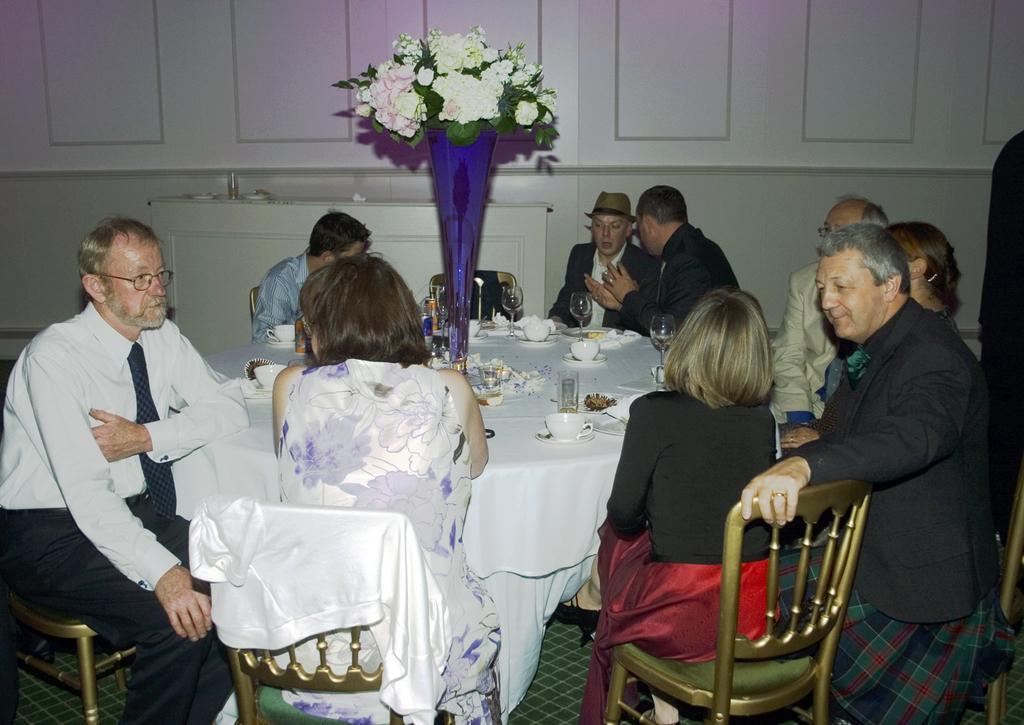In one or two sentences, can you explain what this image depicts? Left side of the image a person is sitting on chair before the table having cup, glasses, flower vase, drinking cans on it. Two woman are sitting in front of the image on chair and few other people are sitting. 